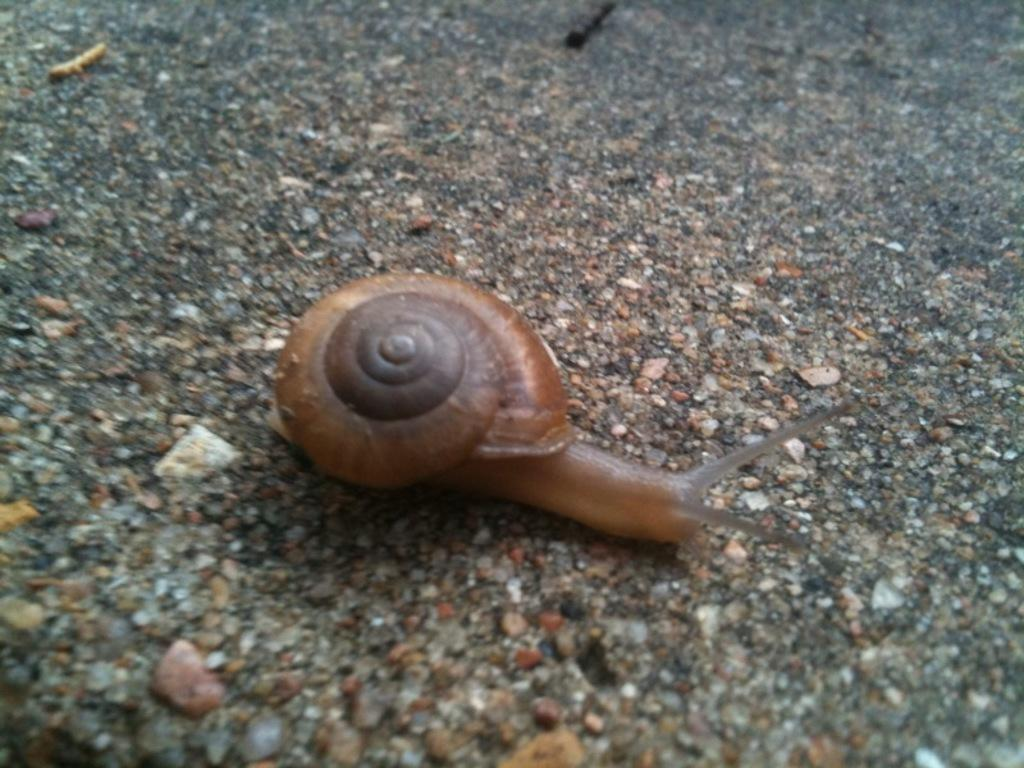What object is present in the image? There is a shell in the image. What is the color of the shell? The shell is brown in color. What creature is inside the shell? There is a snail in the shell. What is the color of the snail? The snail is brown in color. What is the snail doing in the image? The snail is crawling on the floor. How does the snail maintain quiet while wearing jeans in the image? There is no mention of the snail wearing jeans or maintaining quiet in the image. The snail is simply crawling on the floor. 